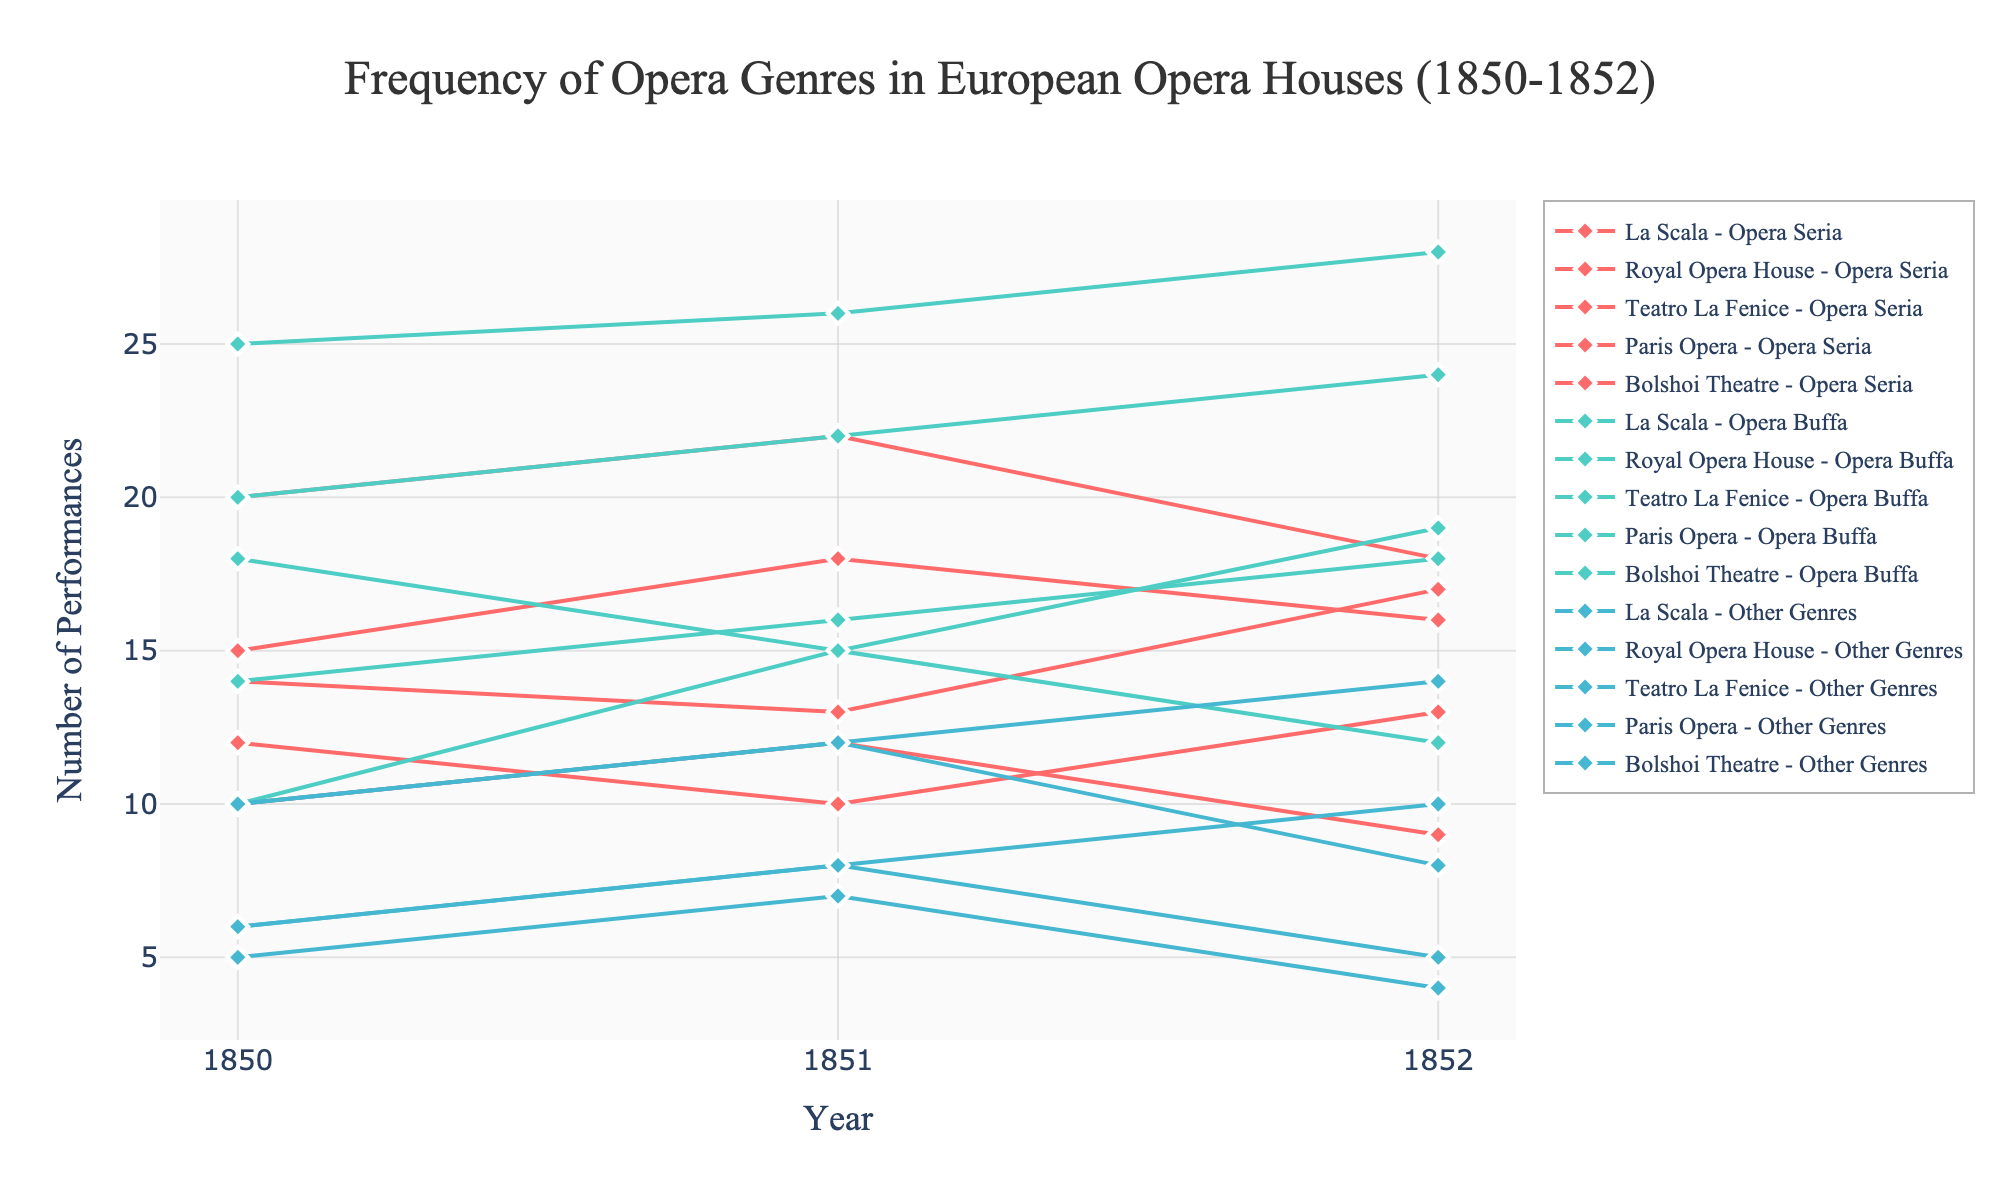What is the title of the plot? The title is usually located at the top of the plot and in this case reads "Frequency of Opera Genres in European Opera Houses (1850-1852)."
Answer: Frequency of Opera Genres in European Opera Houses (1850-1852) How many opera houses are represented in the plot? By looking at the different unique series in the plot, each representing an opera house with various genres, we can count that five opera houses are represented: La Scala, Royal Opera House, Teatro La Fenice, Paris Opera, and Bolshoi Theatre.
Answer: Five Which genre has the highest number of performances at Paris Opera in 1851? From the hover labels on the plot, examine the data points corresponding to Paris Opera in 1851. The number of performances for Opera Seria is 22, for Opera Buffa is 15, and for Other Genres is 12. The highest number of performances is for Opera Seria.
Answer: Opera Seria Compare the frequency of Opera Buffa performances at La Scala and Teatro La Fenice in 1850. Which has more performances? Look at the data points for Opera Buffa at La Scala and Teatro La Fenice in 1850. La Scala has 20 performances, while Teatro La Fenice has 25 performances for Opera Buffa. Teatro La Fenice has more performances.
Answer: Teatro La Fenice What is the trend of Opera Seria performances at the Royal Opera House from 1850 to 1852? Trace the line for Opera Seria performances at the Royal Opera House across the years 1850 to 1852. In 1850 there were 12 performances, in 1851 this number decreased to 10, and then in 1852 it increased to 13. The trend is initially downward and then upward.
Answer: Downward and then upward Which opera house had the highest total number of opera performances in 1852? Sum the total performances of all genres (Opera Seria, Opera Buffa, Other Genres) for each opera house in 1852. La Scala: 16+24+4 = 44, Royal Opera House: 13+19+8 = 40, Teatro La Fenice: 17+28+5 = 50, Paris Opera: 18+12+14 = 44, Bolshoi Theatre: 9+18+10 = 37. Teatro La Fenice has the highest total.
Answer: Teatro La Fenice What is the total number of Opera Buffa performances across all opera houses in 1850? Add the number of Opera Buffa performances for all the listed opera houses in 1850: La Scala (20), Royal Opera House (18), Teatro La Fenice (25), Paris Opera (10), Bolshoi Theatre (14). The sum is 20 + 18 + 25 + 10 + 14 = 87.
Answer: 87 performances Which genre had the smallest increase in performances at La Scala from 1850 to 1851? Check the difference in the number of performances at La Scala for each genre from 1850 to 1851: Opera Seria increased by 18-15=3, Opera Buffa increased by 22-20=2, and Other Genres increased by 7-5=2. Both Opera Buffa and Other Genres had the same smallest increase of 2 performances.
Answer: Opera Buffa and Other Genres What is the average number of performances for Other Genres at Bolshoi Theatre over the three years? Add the number of performances for "Other Genres" at Bolshoi Theatre across the three years: 1850 (6), 1851 (8), and 1852 (10). The sum is 6 + 8 + 10 = 24. The average is 24/3 = 8.
Answer: 8 Between Opera Seria and Opera Buffa, which genre showed more consistency in performance frequency at the Teatro La Fenice from 1850 to 1852? Look at the number of performances for both genres at Teatro La Fenice over the three years. For Opera Seria: 14, 13, 17 (fluctuation range: 17-13=4), and for Opera Buffa: 25, 26, 28 (fluctuation range: 28-25=3). Opera Buffa shows more consistency with a smaller range of variation.
Answer: Opera Buffa 